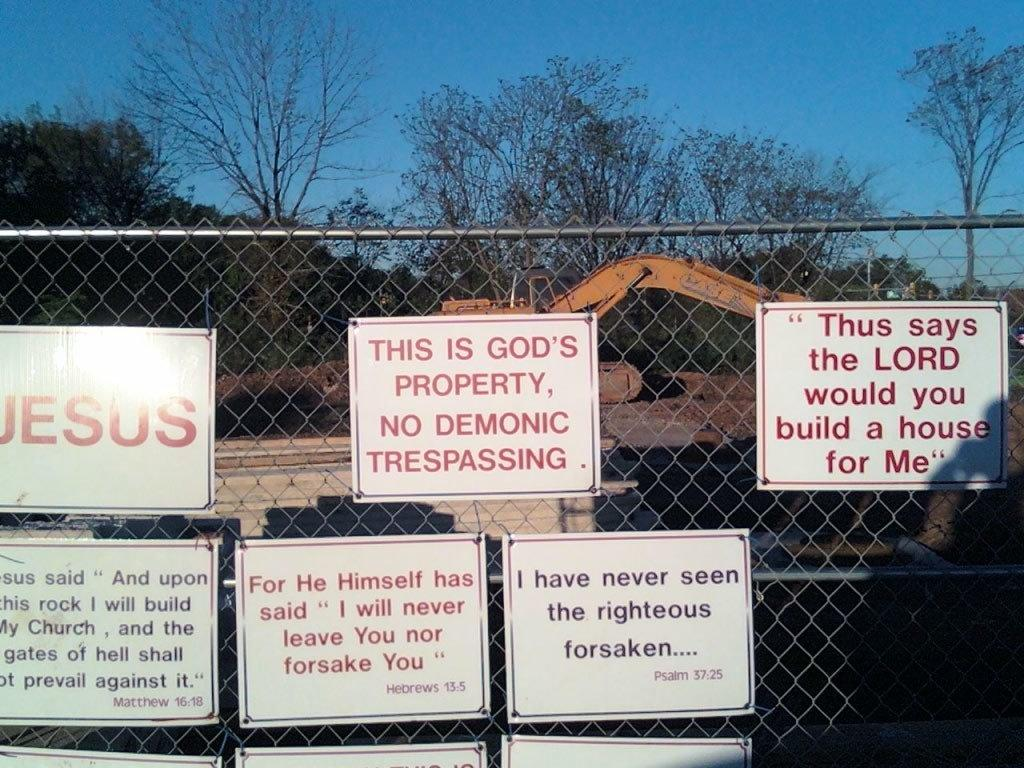<image>
Share a concise interpretation of the image provided. Various religions signs adorn a construction site's fence. 